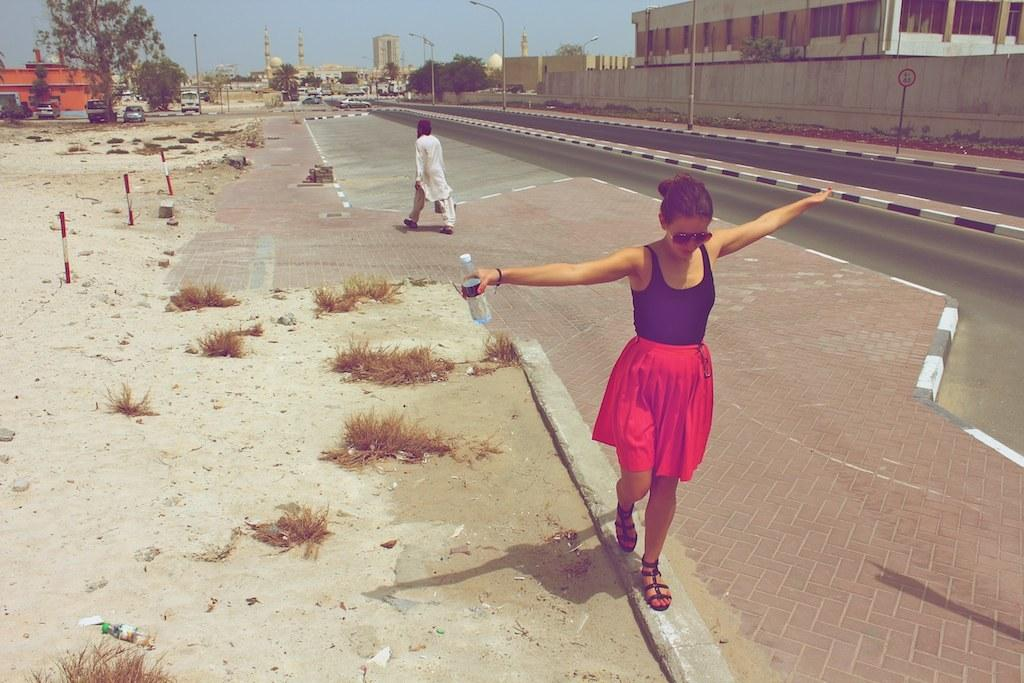What is the person in the foreground of the image holding? The person in the foreground is holding a bottle. What is happening in the background of the image? There is a person walking in the background, and there are buildings, a wall, sign boards, poles, light poles, vehicles, and trees visible. Can you describe the environment in the background of the image? The background features an urban environment with buildings, a wall, sign boards, poles, light poles, vehicles, and trees. How many ladybugs are crawling on the wall in the image? There are no ladybugs present in the image; only the person holding a bottle, the person walking, buildings, a wall, sign boards, poles, light poles, vehicles, and trees are visible. 